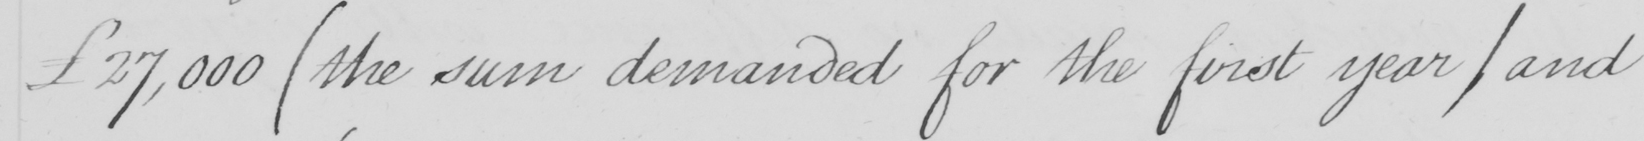Can you read and transcribe this handwriting? £27,000  ( the sum demanded for the first year / and 